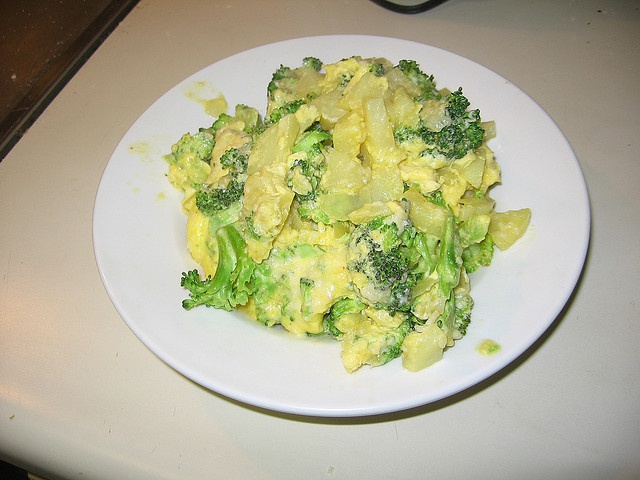Describe the objects in this image and their specific colors. I can see dining table in lightgray, darkgray, tan, beige, and khaki tones, broccoli in black, olive, darkgreen, and khaki tones, broccoli in black, khaki, olive, and darkgreen tones, broccoli in black, tan, khaki, and darkgreen tones, and broccoli in black, olive, and khaki tones in this image. 